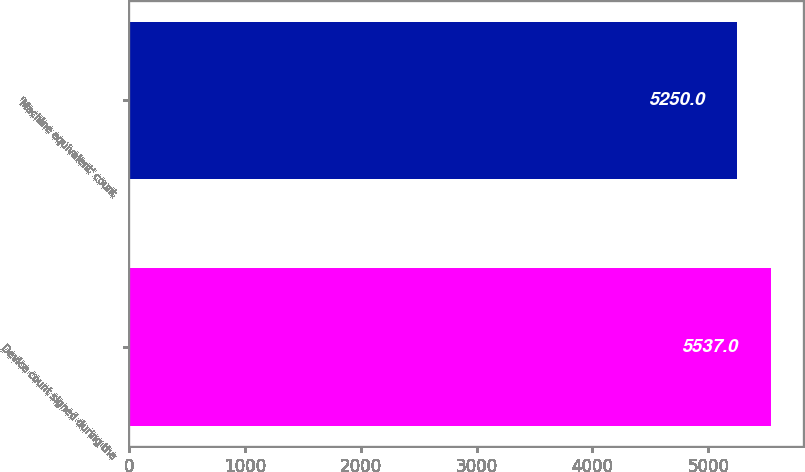<chart> <loc_0><loc_0><loc_500><loc_500><bar_chart><fcel>Device count signed during the<fcel>'Machine equivalent' count<nl><fcel>5537<fcel>5250<nl></chart> 